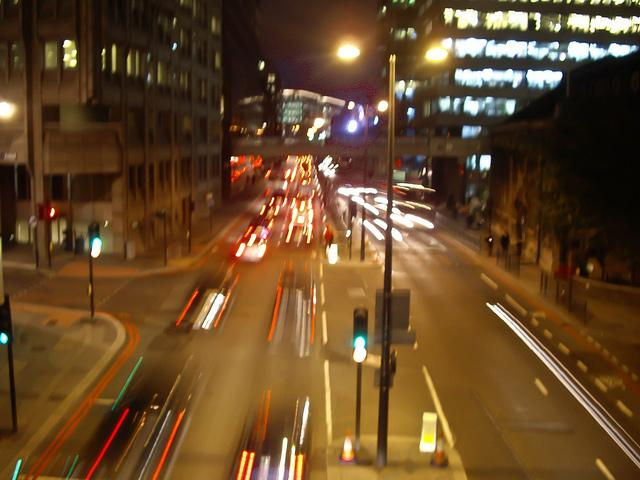What is near the cars? street lights 